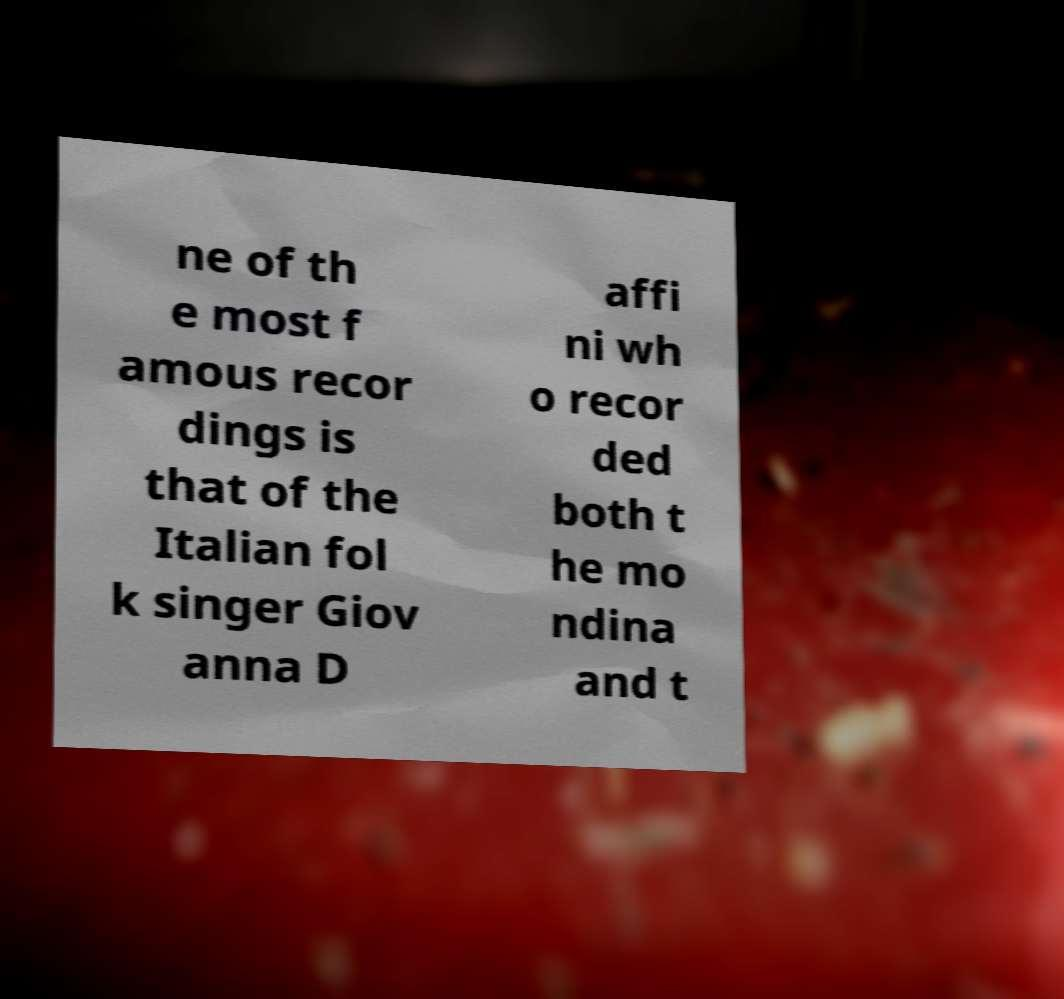Could you assist in decoding the text presented in this image and type it out clearly? ne of th e most f amous recor dings is that of the Italian fol k singer Giov anna D affi ni wh o recor ded both t he mo ndina and t 